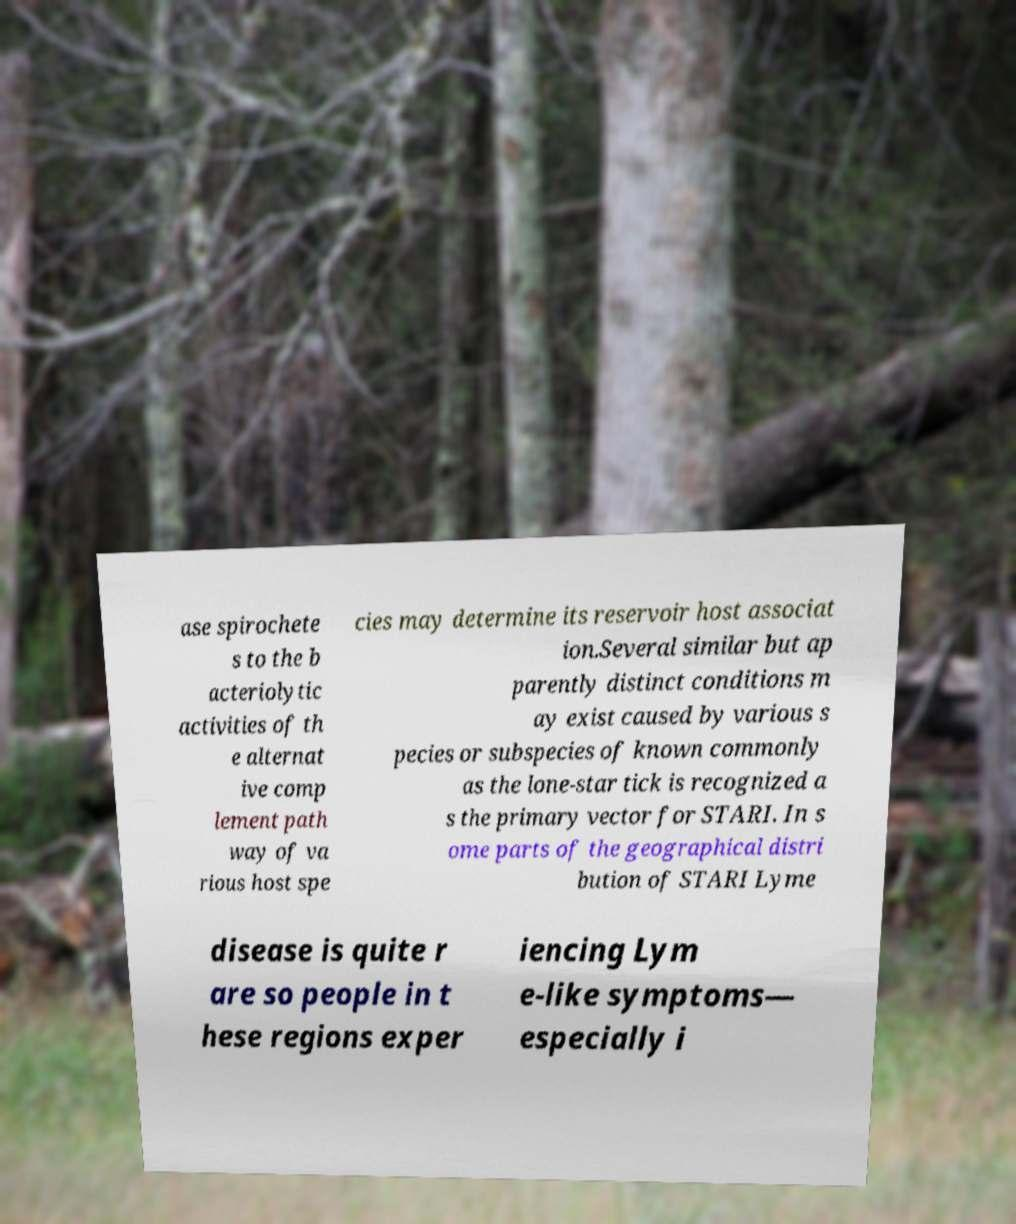I need the written content from this picture converted into text. Can you do that? ase spirochete s to the b acteriolytic activities of th e alternat ive comp lement path way of va rious host spe cies may determine its reservoir host associat ion.Several similar but ap parently distinct conditions m ay exist caused by various s pecies or subspecies of known commonly as the lone-star tick is recognized a s the primary vector for STARI. In s ome parts of the geographical distri bution of STARI Lyme disease is quite r are so people in t hese regions exper iencing Lym e-like symptoms— especially i 